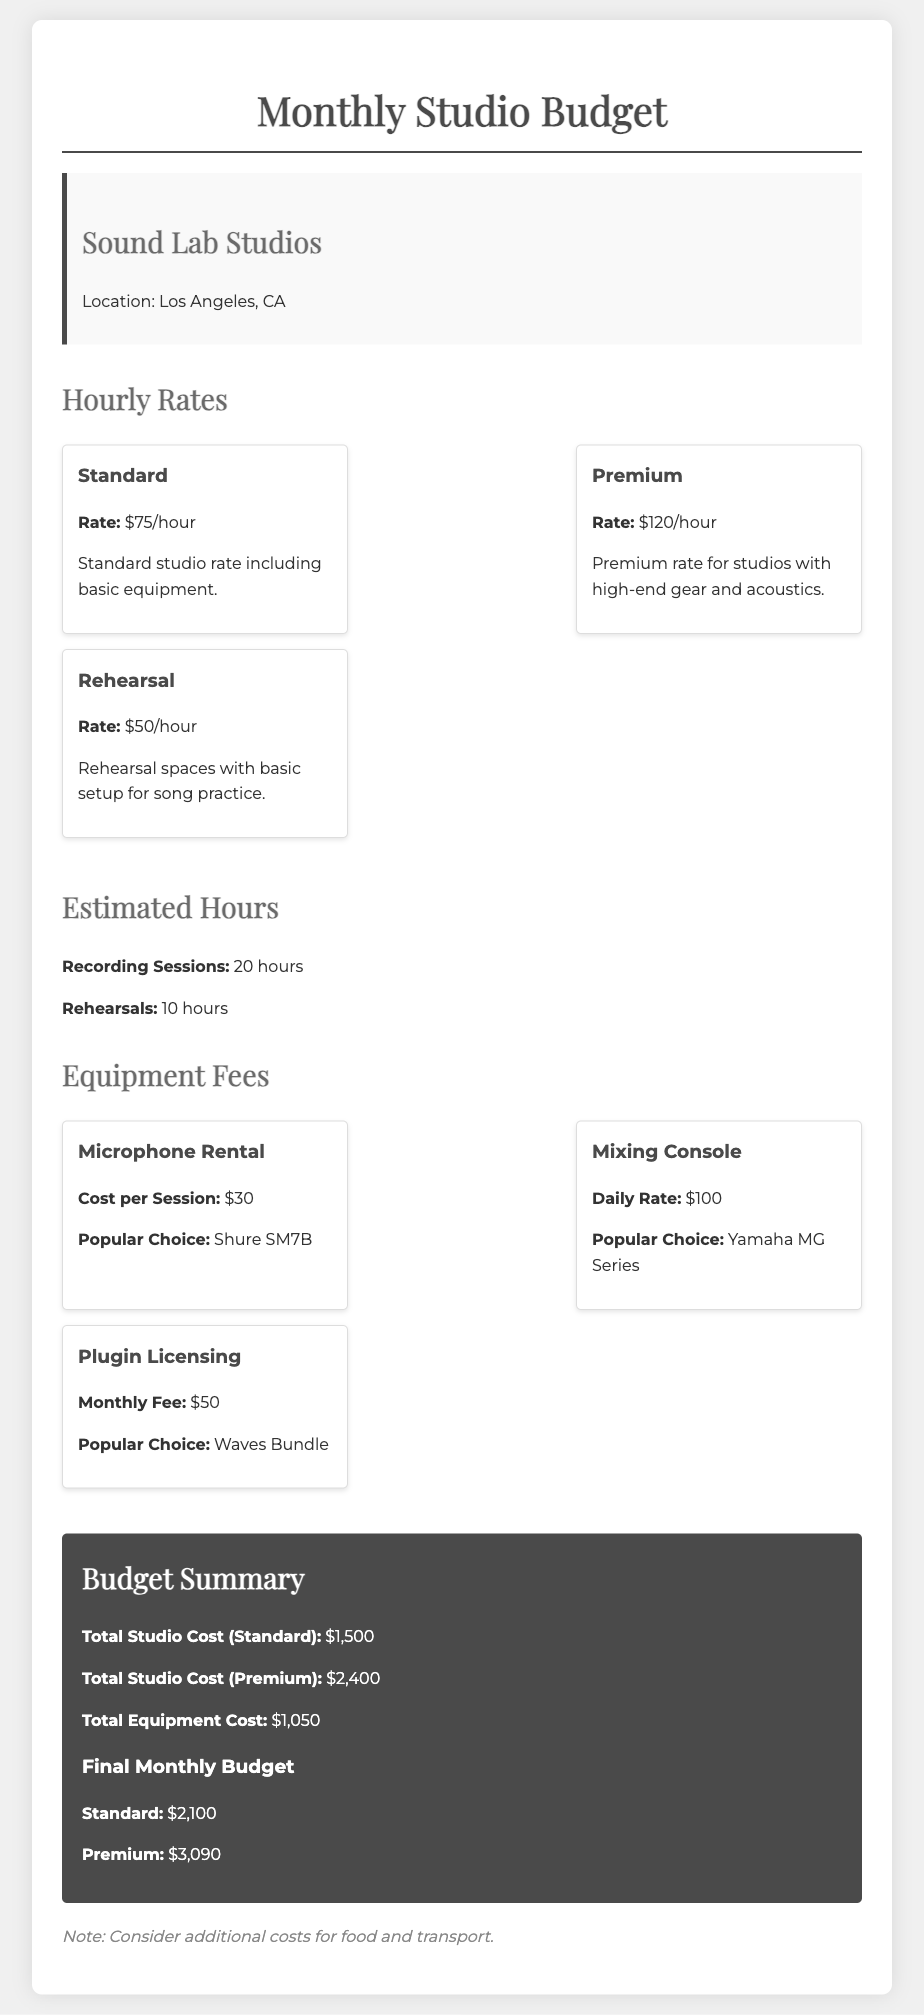What is the standard hourly rate? The standard hourly rate for the studio is listed under the hourly rates section.
Answer: $75/hour What is the total equipment cost? The total equipment cost is specified in the budget summary section.
Answer: $1,050 How many hours are allocated for recording sessions? The document states the total hours for recording sessions in the estimated hours section.
Answer: 20 hours What is the premium hourly rate? The premium hourly rate is mentioned in the hourly rates section.
Answer: $120/hour What is the popular choice for microphone rental? The document specifies the popular microphone choice in the equipment section.
Answer: Shure SM7B What is the final monthly budget for the premium rate? The final monthly budget for the premium rate is provided in the budget summary.
Answer: $3,090 What is the cost per session for microphone rental? The cost per session is noted in the equipment fees section.
Answer: $30 How many hours are allocated for rehearsals? The document gives the number of hours for rehearsals in the estimated hours section.
Answer: 10 hours What is the daily rate for the mixing console? The daily rate for the mixing console can be found in the equipment fees section.
Answer: $100 